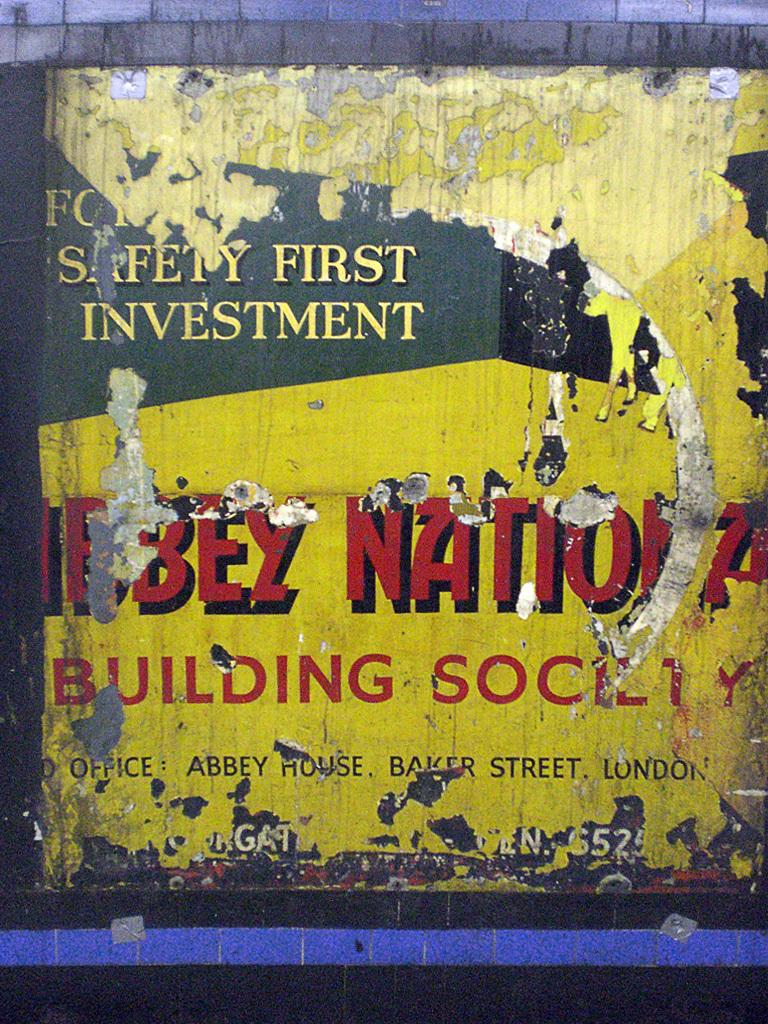<image>
Present a compact description of the photo's key features. A badly damaged poster with a lot of obscured words but on which safety first investment can still be read. 